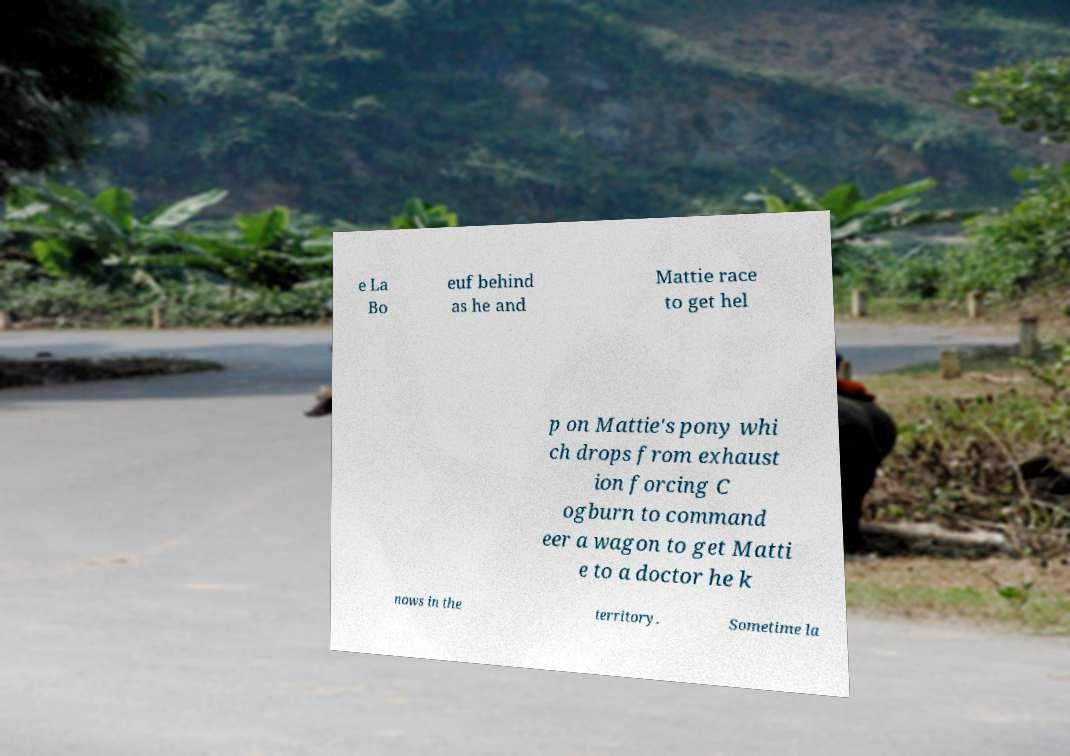Can you read and provide the text displayed in the image?This photo seems to have some interesting text. Can you extract and type it out for me? e La Bo euf behind as he and Mattie race to get hel p on Mattie's pony whi ch drops from exhaust ion forcing C ogburn to command eer a wagon to get Matti e to a doctor he k nows in the territory. Sometime la 